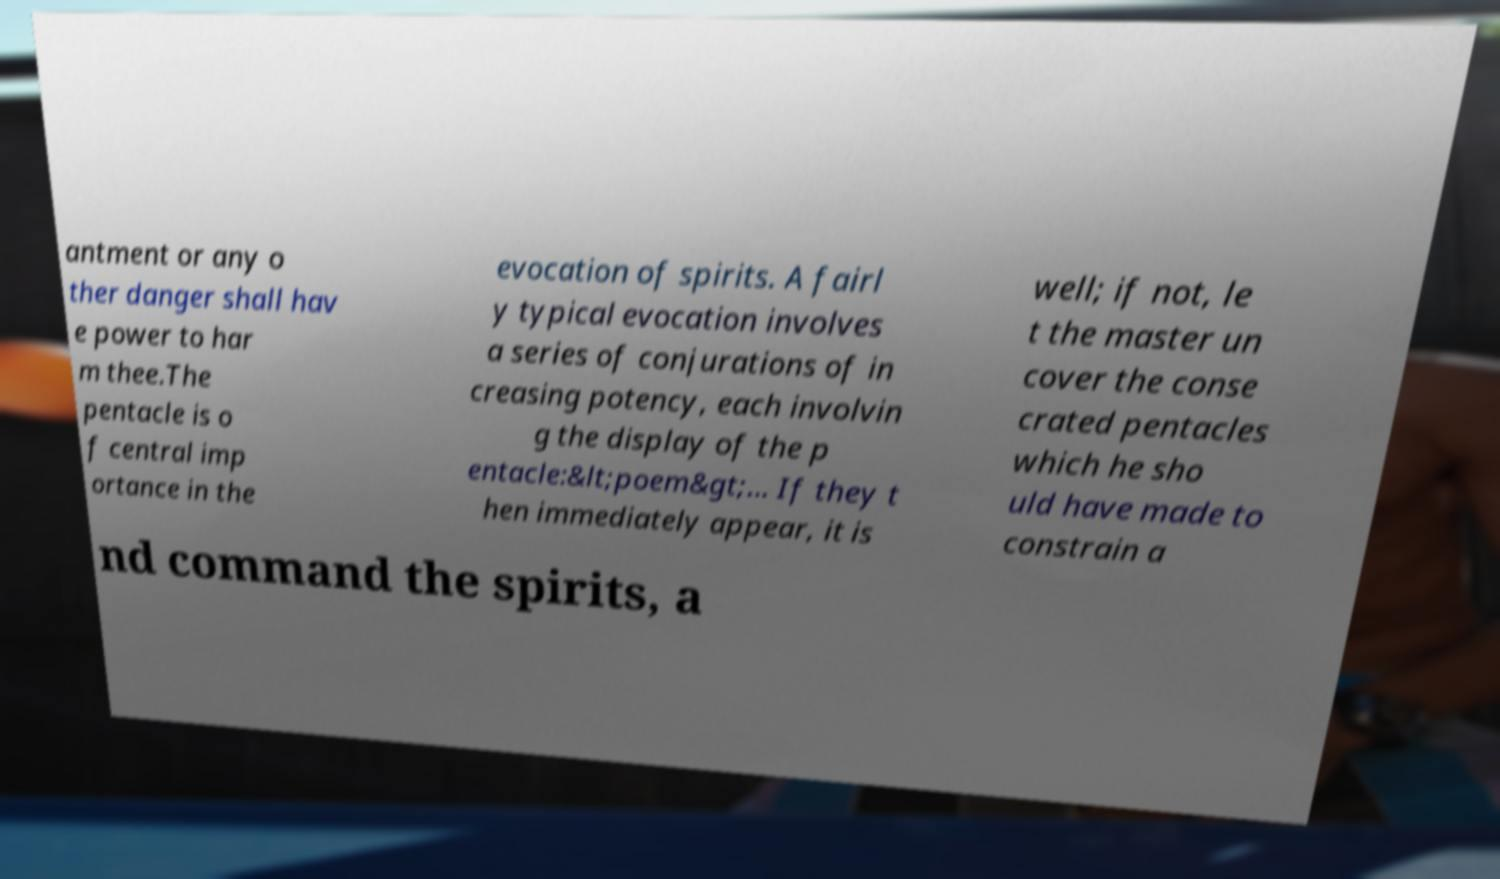For documentation purposes, I need the text within this image transcribed. Could you provide that? antment or any o ther danger shall hav e power to har m thee.The pentacle is o f central imp ortance in the evocation of spirits. A fairl y typical evocation involves a series of conjurations of in creasing potency, each involvin g the display of the p entacle:&lt;poem&gt;... If they t hen immediately appear, it is well; if not, le t the master un cover the conse crated pentacles which he sho uld have made to constrain a nd command the spirits, a 